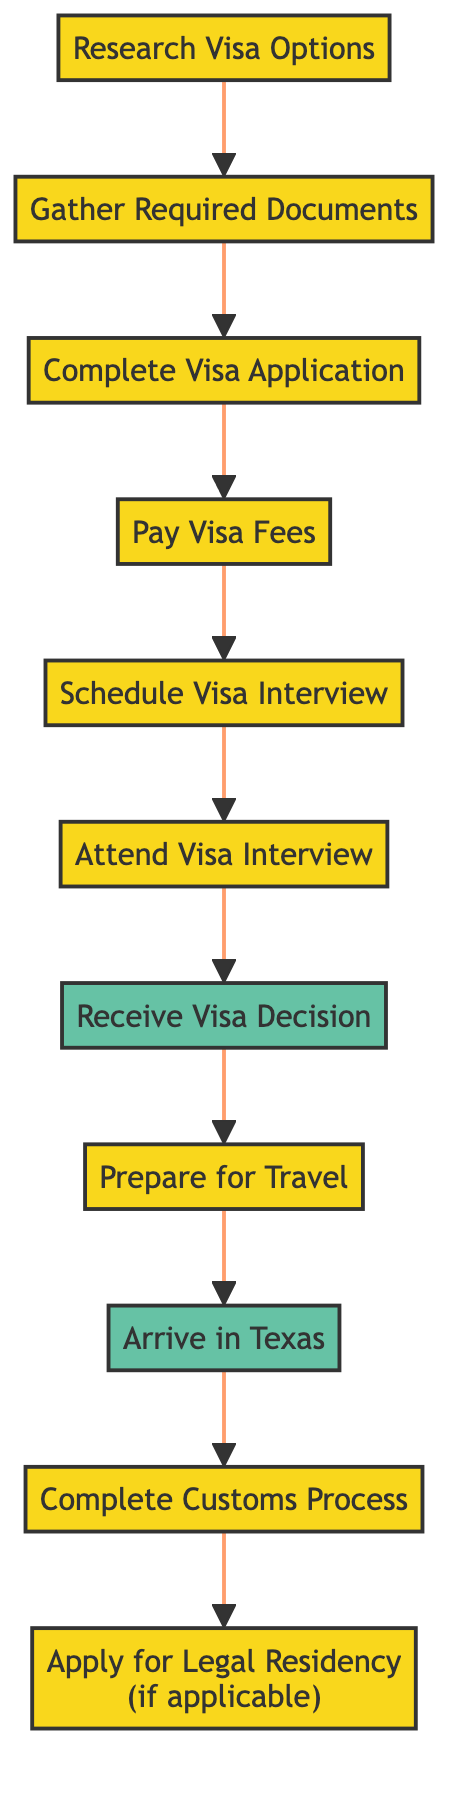What is the first step in the immigration process flow? The first step in the diagram is "Research Visa Options," which is the starting node of the directed graph.
Answer: Research Visa Options How many nodes are there in total? By counting all the unique steps and outcomes represented in the diagram, there are a total of 11 nodes.
Answer: 11 What is the outcome after attending the visa interview? The diagram shows that the outcome after attending the visa interview is "Receive Visa Decision," which follows the "Attend Visa Interview" node.
Answer: Receive Visa Decision What step comes immediately after paying visa fees? The diagram indicates that "Schedule Visa Interview" comes directly after "Pay Visa Fees."
Answer: Schedule Visa Interview What is the final outcome in the process flow? The last node in the diagram shows that the final outcome is "Apply for Legal Residency (if applicable)."
Answer: Apply for Legal Residency (if applicable) Which process follows receiving the visa decision? Following "Receive Visa Decision," the next step in the process is "Prepare for Travel," as indicated by the directed connection.
Answer: Prepare for Travel How many processes are there before the visa interview? There are five processes before the visa interview: "Research Visa Options," "Gather Required Documents," "Complete Visa Application," "Pay Visa Fees," and "Schedule Visa Interview," making a total of five.
Answer: 5 What type of flow structure is used in this diagram? The diagram utilizes a directed graph structure, where nodes represent processes and outcomes, and arrows indicate the flow direction between them.
Answer: Directed graph What comes after arriving in Texas? The next step in the process after "Arrive in Texas" is "Complete Customs Process," as shown in the directed graph flow.
Answer: Complete Customs Process 